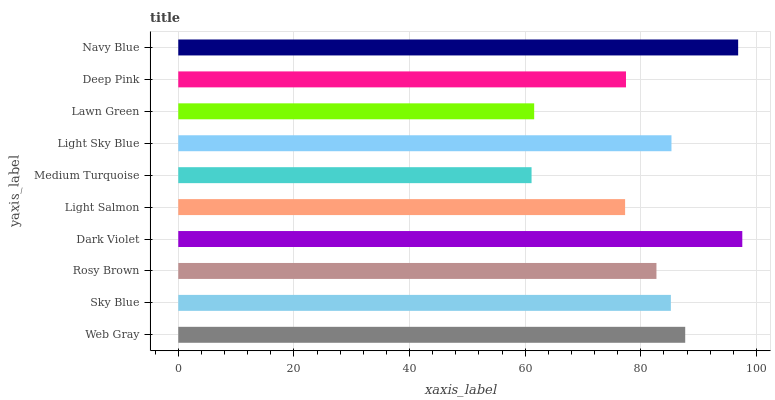Is Medium Turquoise the minimum?
Answer yes or no. Yes. Is Dark Violet the maximum?
Answer yes or no. Yes. Is Sky Blue the minimum?
Answer yes or no. No. Is Sky Blue the maximum?
Answer yes or no. No. Is Web Gray greater than Sky Blue?
Answer yes or no. Yes. Is Sky Blue less than Web Gray?
Answer yes or no. Yes. Is Sky Blue greater than Web Gray?
Answer yes or no. No. Is Web Gray less than Sky Blue?
Answer yes or no. No. Is Sky Blue the high median?
Answer yes or no. Yes. Is Rosy Brown the low median?
Answer yes or no. Yes. Is Deep Pink the high median?
Answer yes or no. No. Is Web Gray the low median?
Answer yes or no. No. 